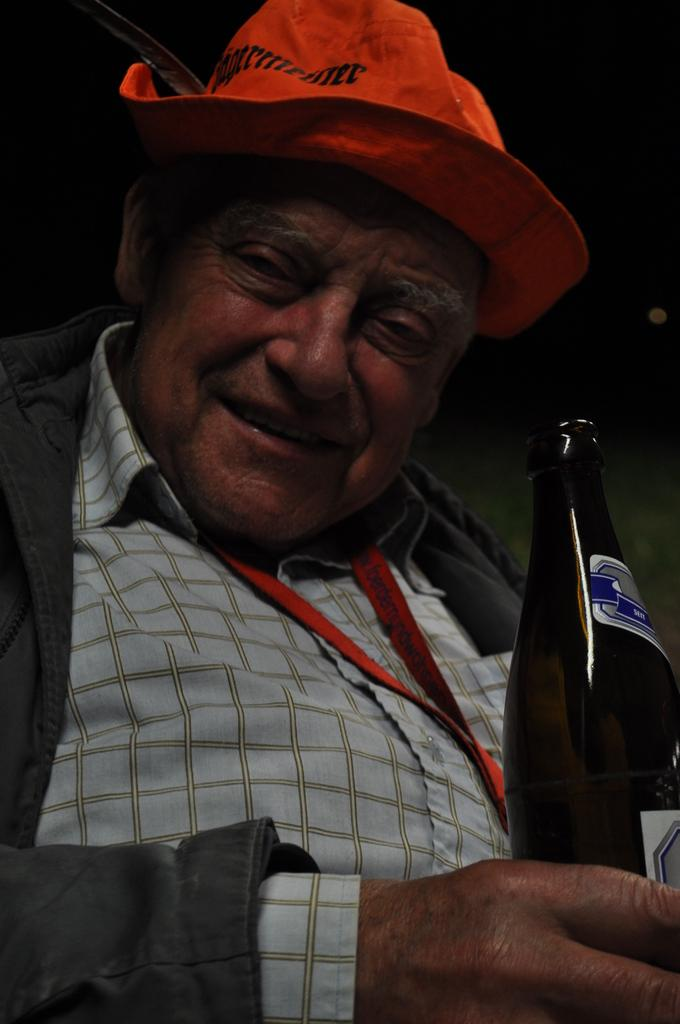What is the main subject of the image? The main subject of the image is a man. What is the man holding in the image? The man is holding a bottle in the image. What can be seen on the man's head? The man is wearing an orange hat in the image. What type of legal advice is the man providing in the image? There is no indication in the image that the man is a lawyer or providing legal advice. 